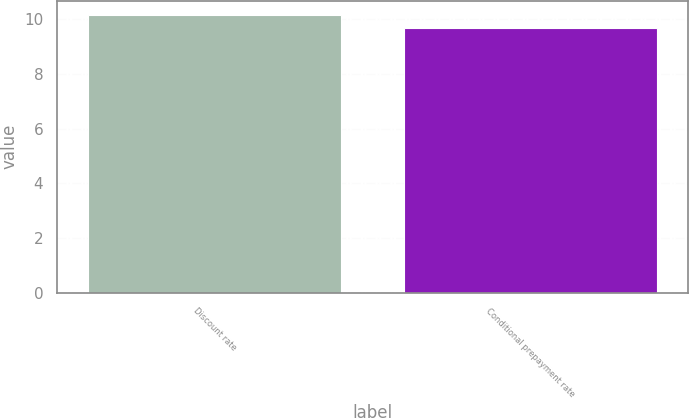<chart> <loc_0><loc_0><loc_500><loc_500><bar_chart><fcel>Discount rate<fcel>Conditional prepayment rate<nl><fcel>10.16<fcel>9.66<nl></chart> 